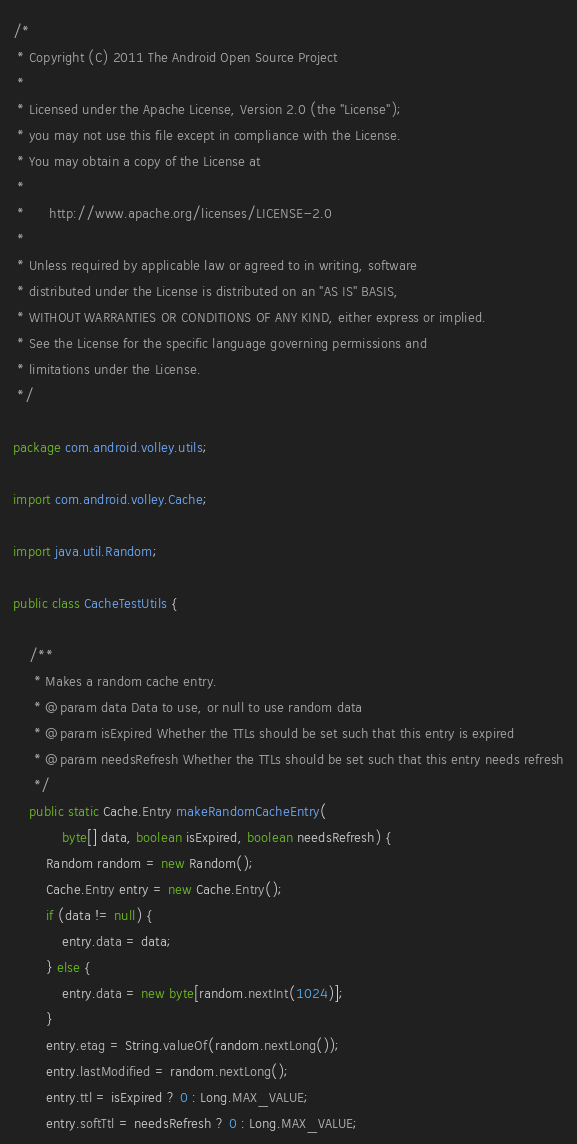<code> <loc_0><loc_0><loc_500><loc_500><_Java_>/*
 * Copyright (C) 2011 The Android Open Source Project
 *
 * Licensed under the Apache License, Version 2.0 (the "License");
 * you may not use this file except in compliance with the License.
 * You may obtain a copy of the License at
 *
 *      http://www.apache.org/licenses/LICENSE-2.0
 *
 * Unless required by applicable law or agreed to in writing, software
 * distributed under the License is distributed on an "AS IS" BASIS,
 * WITHOUT WARRANTIES OR CONDITIONS OF ANY KIND, either express or implied.
 * See the License for the specific language governing permissions and
 * limitations under the License.
 */

package com.android.volley.utils;

import com.android.volley.Cache;

import java.util.Random;

public class CacheTestUtils {

    /**
     * Makes a random cache entry.
     * @param data Data to use, or null to use random data
     * @param isExpired Whether the TTLs should be set such that this entry is expired
     * @param needsRefresh Whether the TTLs should be set such that this entry needs refresh
     */
    public static Cache.Entry makeRandomCacheEntry(
            byte[] data, boolean isExpired, boolean needsRefresh) {
        Random random = new Random();
        Cache.Entry entry = new Cache.Entry();
        if (data != null) {
            entry.data = data;
        } else {
            entry.data = new byte[random.nextInt(1024)];
        }
        entry.etag = String.valueOf(random.nextLong());
        entry.lastModified = random.nextLong();
        entry.ttl = isExpired ? 0 : Long.MAX_VALUE;
        entry.softTtl = needsRefresh ? 0 : Long.MAX_VALUE;</code> 